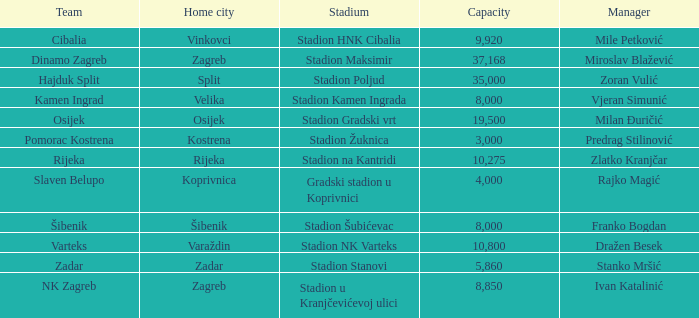What team that has a Home city of Zadar? Zadar. 